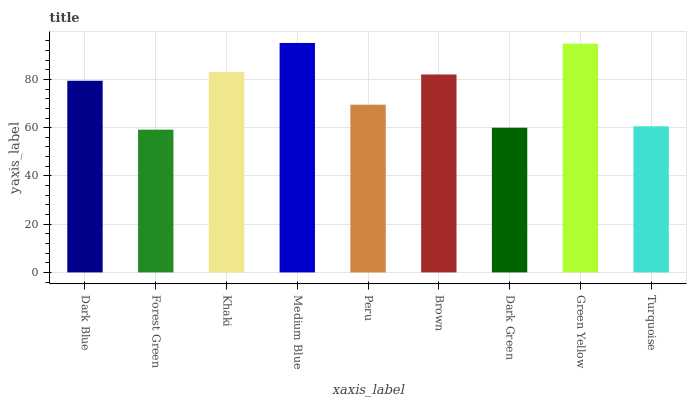Is Forest Green the minimum?
Answer yes or no. Yes. Is Medium Blue the maximum?
Answer yes or no. Yes. Is Khaki the minimum?
Answer yes or no. No. Is Khaki the maximum?
Answer yes or no. No. Is Khaki greater than Forest Green?
Answer yes or no. Yes. Is Forest Green less than Khaki?
Answer yes or no. Yes. Is Forest Green greater than Khaki?
Answer yes or no. No. Is Khaki less than Forest Green?
Answer yes or no. No. Is Dark Blue the high median?
Answer yes or no. Yes. Is Dark Blue the low median?
Answer yes or no. Yes. Is Peru the high median?
Answer yes or no. No. Is Medium Blue the low median?
Answer yes or no. No. 